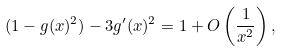Convert formula to latex. <formula><loc_0><loc_0><loc_500><loc_500>( 1 - g ( x ) ^ { 2 } ) - 3 g ^ { \prime } ( x ) ^ { 2 } = 1 + O \left ( \frac { 1 } { x ^ { 2 } } \right ) ,</formula> 